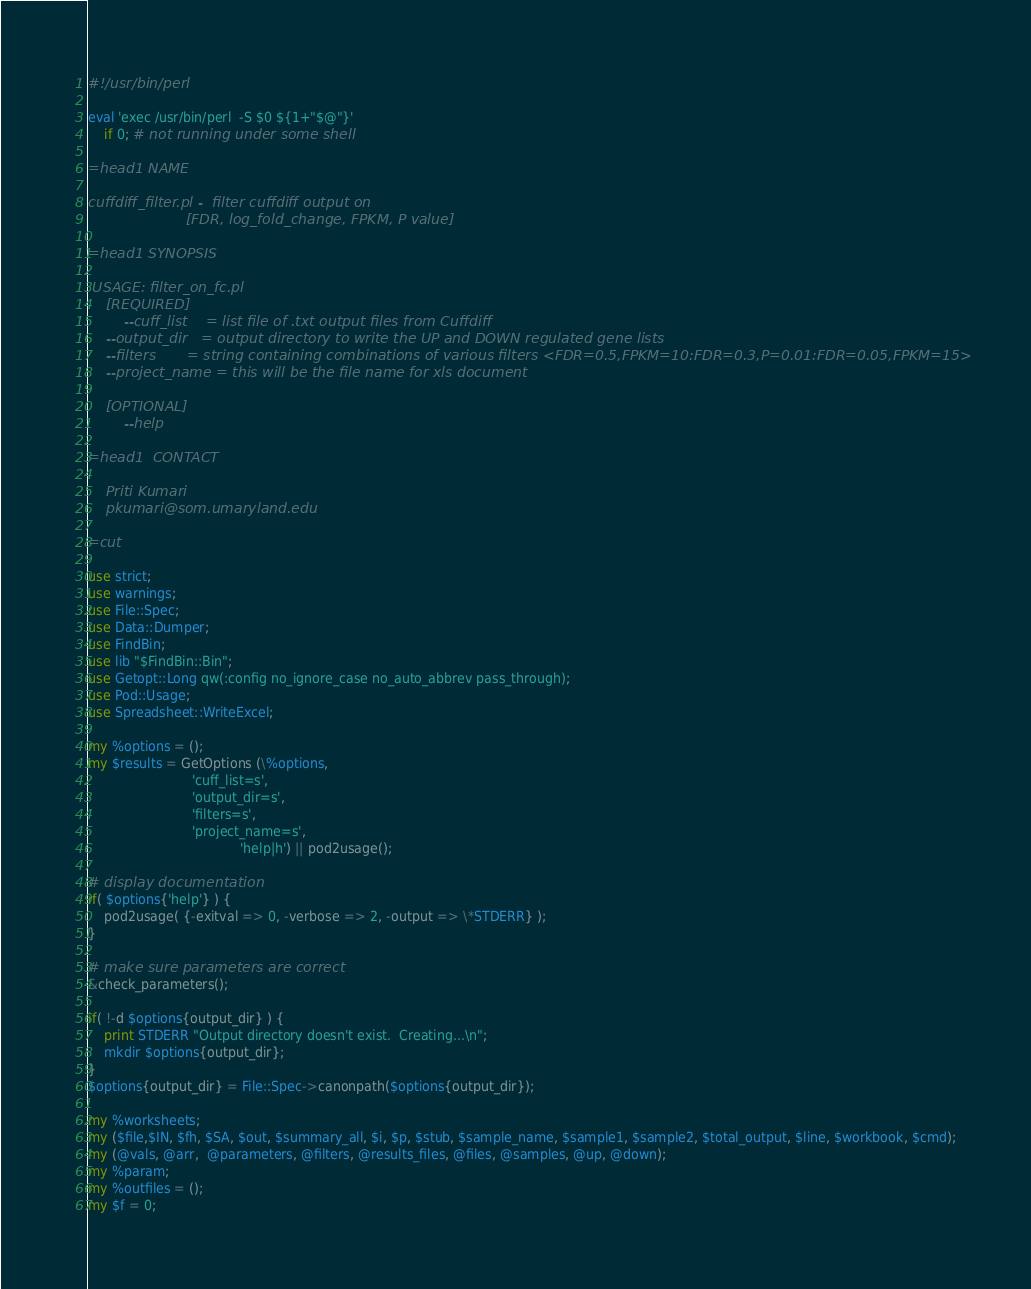<code> <loc_0><loc_0><loc_500><loc_500><_Perl_>#!/usr/bin/perl

eval 'exec /usr/bin/perl  -S $0 ${1+"$@"}'
    if 0; # not running under some shell

=head1 NAME

cuffdiff_filter.pl -  filter cuffdiff output on 
                      [FDR, log_fold_change, FPKM, P value]

=head1 SYNOPSIS

 USAGE: filter_on_fc.pl
	[REQUIRED]
        --cuff_list    = list file of .txt output files from Cuffdiff
	--output_dir   = output directory to write the UP and DOWN regulated gene lists	
	--filters       = string containing combinations of various filters <FDR=0.5,FPKM=10:FDR=0.3,P=0.01:FDR=0.05,FPKM=15>
	--project_name = this will be the file name for xls document

	[OPTIONAL]
        --help

=head1  CONTACT

    Priti Kumari
    pkumari@som.umaryland.edu

=cut

use strict;
use warnings;
use File::Spec;
use Data::Dumper;
use FindBin;
use lib "$FindBin::Bin";
use Getopt::Long qw(:config no_ignore_case no_auto_abbrev pass_through);
use Pod::Usage;
use Spreadsheet::WriteExcel;

my %options = ();
my $results = GetOptions (\%options,
						  'cuff_list=s',
						  'output_dir=s',
						  'filters=s',
						  'project_name=s',
			                          'help|h') || pod2usage();

# display documentation
if( $options{'help'} ) {
    pod2usage( {-exitval => 0, -verbose => 2, -output => \*STDERR} );
}

# make sure parameters are correct
&check_parameters();

if( !-d $options{output_dir} ) {
	print STDERR "Output directory doesn't exist.  Creating...\n";
	mkdir $options{output_dir};
}
$options{output_dir} = File::Spec->canonpath($options{output_dir});

my %worksheets;
my ($file,$IN, $fh, $SA, $out, $summary_all, $i, $p, $stub, $sample_name, $sample1, $sample2, $total_output, $line, $workbook, $cmd);
my (@vals, @arr,  @parameters, @filters, @results_files, @files, @samples, @up, @down);
my %param;
my %outfiles = ();
my $f = 0;

</code> 